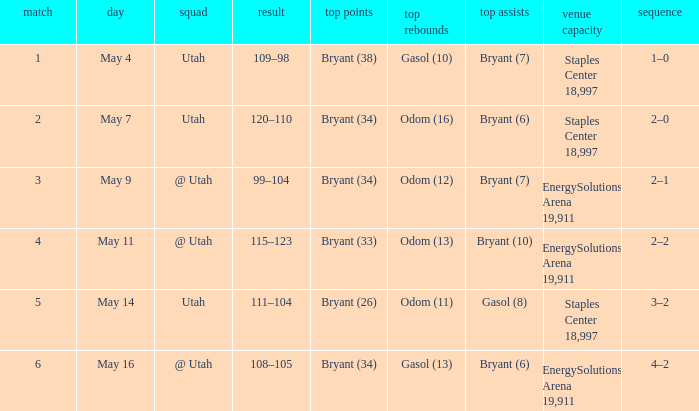What is the High rebounds with a High assists with bryant (7), and a Team of @ utah? Odom (12). 